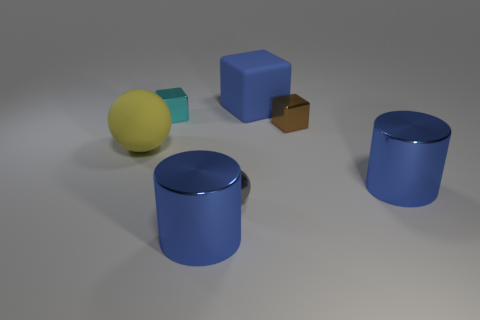Subtract all small shiny blocks. How many blocks are left? 1 Add 2 big blue cubes. How many objects exist? 9 Subtract all blue blocks. How many blocks are left? 2 Subtract 1 blocks. How many blocks are left? 2 Subtract all cylinders. How many objects are left? 5 Subtract all cyan blocks. Subtract all cyan spheres. How many blocks are left? 2 Add 7 gray metallic spheres. How many gray metallic spheres exist? 8 Subtract 0 red cubes. How many objects are left? 7 Subtract all gray metal spheres. Subtract all gray balls. How many objects are left? 5 Add 3 metal balls. How many metal balls are left? 4 